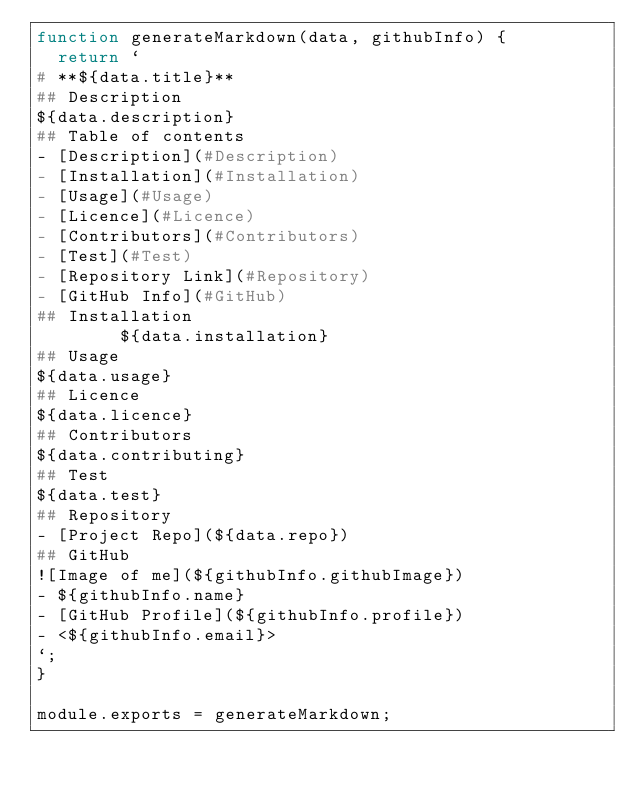<code> <loc_0><loc_0><loc_500><loc_500><_JavaScript_>function generateMarkdown(data, githubInfo) {
  return `
# **${data.title}**
## Description 
${data.description}
## Table of contents
- [Description](#Description)
- [Installation](#Installation)
- [Usage](#Usage)
- [Licence](#Licence)
- [Contributors](#Contributors)
- [Test](#Test)
- [Repository Link](#Repository)
- [GitHub Info](#GitHub) 
## Installation
        ${data.installation}
## Usage
${data.usage}
## Licence
${data.licence}
## Contributors
${data.contributing}
## Test
${data.test}
## Repository
- [Project Repo](${data.repo})
## GitHub
![Image of me](${githubInfo.githubImage})
- ${githubInfo.name}
- [GitHub Profile](${githubInfo.profile})
- <${githubInfo.email}>
`;
}

module.exports = generateMarkdown;</code> 